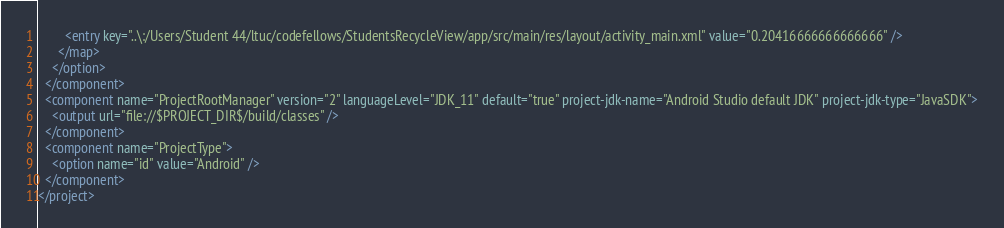Convert code to text. <code><loc_0><loc_0><loc_500><loc_500><_XML_>        <entry key="..\:/Users/Student 44/ltuc/codefellows/StudentsRecycleView/app/src/main/res/layout/activity_main.xml" value="0.20416666666666666" />
      </map>
    </option>
  </component>
  <component name="ProjectRootManager" version="2" languageLevel="JDK_11" default="true" project-jdk-name="Android Studio default JDK" project-jdk-type="JavaSDK">
    <output url="file://$PROJECT_DIR$/build/classes" />
  </component>
  <component name="ProjectType">
    <option name="id" value="Android" />
  </component>
</project></code> 